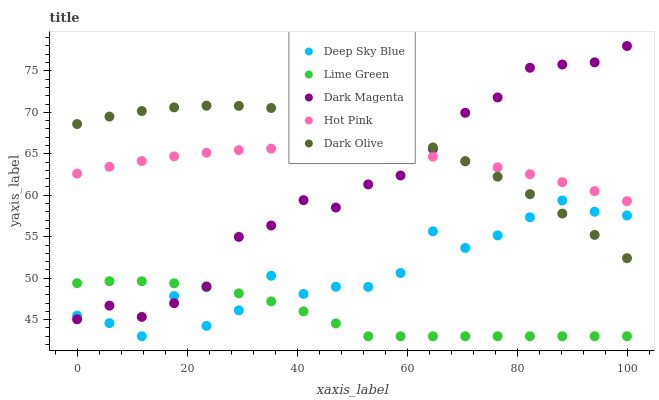Does Lime Green have the minimum area under the curve?
Answer yes or no. Yes. Does Dark Olive have the maximum area under the curve?
Answer yes or no. Yes. Does Hot Pink have the minimum area under the curve?
Answer yes or no. No. Does Hot Pink have the maximum area under the curve?
Answer yes or no. No. Is Hot Pink the smoothest?
Answer yes or no. Yes. Is Deep Sky Blue the roughest?
Answer yes or no. Yes. Is Lime Green the smoothest?
Answer yes or no. No. Is Lime Green the roughest?
Answer yes or no. No. Does Lime Green have the lowest value?
Answer yes or no. Yes. Does Hot Pink have the lowest value?
Answer yes or no. No. Does Dark Magenta have the highest value?
Answer yes or no. Yes. Does Hot Pink have the highest value?
Answer yes or no. No. Is Lime Green less than Dark Olive?
Answer yes or no. Yes. Is Hot Pink greater than Deep Sky Blue?
Answer yes or no. Yes. Does Deep Sky Blue intersect Dark Magenta?
Answer yes or no. Yes. Is Deep Sky Blue less than Dark Magenta?
Answer yes or no. No. Is Deep Sky Blue greater than Dark Magenta?
Answer yes or no. No. Does Lime Green intersect Dark Olive?
Answer yes or no. No. 